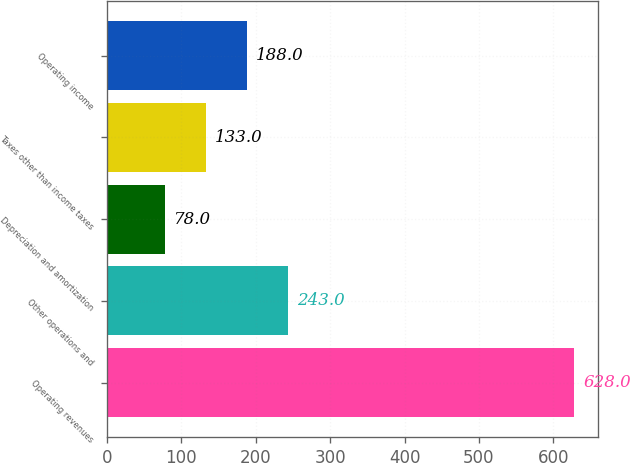Convert chart. <chart><loc_0><loc_0><loc_500><loc_500><bar_chart><fcel>Operating revenues<fcel>Other operations and<fcel>Depreciation and amortization<fcel>Taxes other than income taxes<fcel>Operating income<nl><fcel>628<fcel>243<fcel>78<fcel>133<fcel>188<nl></chart> 